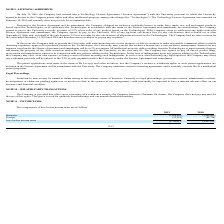According to Protagenic Therapeutics's financial document, What is the company's domestic loss before income tax in 2019? According to the financial document, 1,698,689. The relevant text states: "Domestic (1,698,689) (2,468,805)..." Also, What is the company's domestic loss before income tax in 2018? According to the financial document, 2,468,805. The relevant text states: "Domestic (1,698,689) (2,468,805)..." Also, What is the company's foreign loss before income tax in 2019? According to the financial document, 52,222. The relevant text states: "Foreign (52,222) (88,726)..." Also, can you calculate: What is the company's percentage change in foreign loss between 2018 and 2019? To answer this question, I need to perform calculations using the financial data. The calculation is: (52,222 - 88,726)/88,726 , which equals -41.14 (percentage). This is based on the information: "Foreign (52,222) (88,726) Foreign (52,222) (88,726)..." The key data points involved are: 52,222, 88,726. Also, can you calculate: What is the change in the total loss before income taxes between 2018 and 2019? Based on the calculation: 1,750,911 - 2,557,531 , the result is -806620. This is based on the information: "Loss before income taxes (1,750,911 ) (2,557,531 ) Loss before income taxes (1,750,911 ) (2,557,531 )..." The key data points involved are: 1,750,911, 2,557,531. Also, can you calculate: What is the change in the domestic losses between 2018 and 2019? Based on the calculation: 1,698,689 - 2,468,805 , the result is -770116. This is based on the information: "Domestic (1,698,689) (2,468,805) Domestic (1,698,689) (2,468,805)..." The key data points involved are: 1,698,689, 2,468,805. 